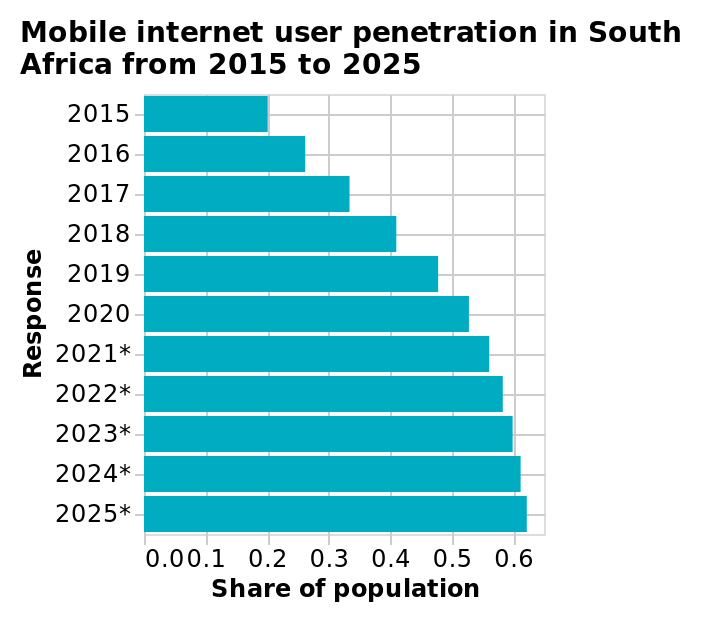<image>
please enumerates aspects of the construction of the chart Here a bar diagram is titled Mobile internet user penetration in South Africa from 2015 to 2025. The y-axis measures Response using categorical scale from 2015 to 2025* while the x-axis plots Share of population using scale of range 0.0 to 0.6. Offer a thorough analysis of the image. The usage of mobile internet has increased clear on year. How has the usage of mobile internet changed?  The usage of mobile internet has increased clear on year. What does the y-axis measure in the bar diagram? The y-axis measures the response using a categorical scale from 2015 to 2025. 